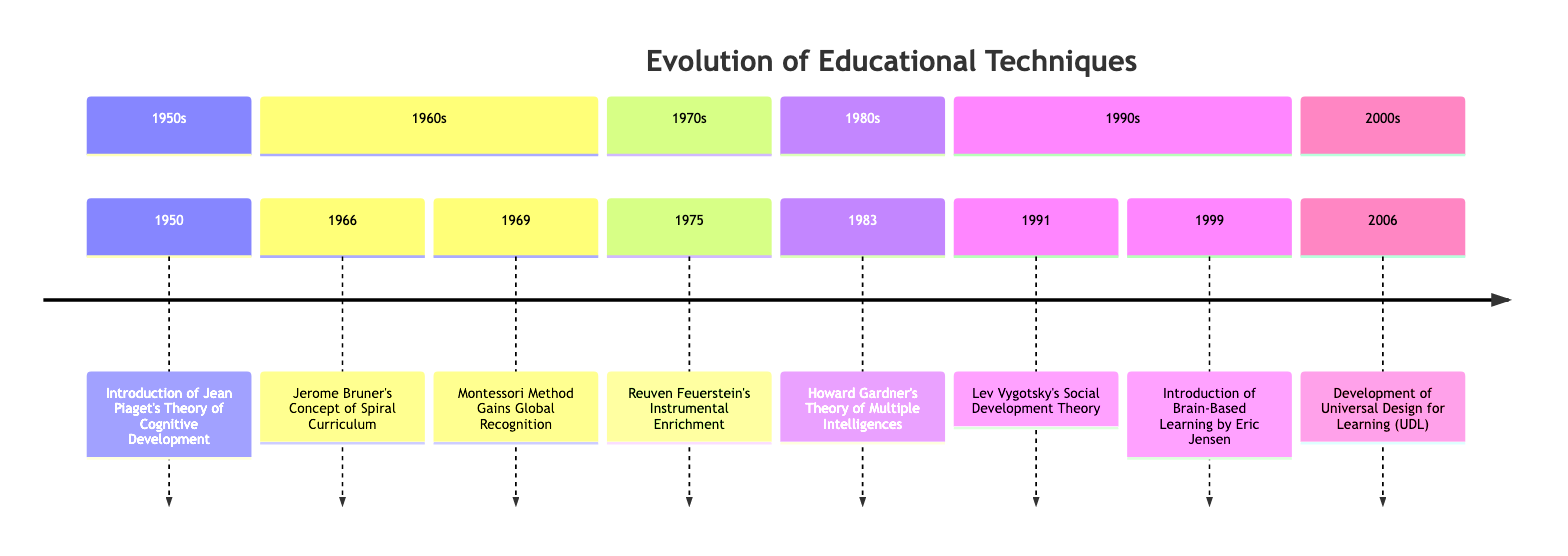What year was Jean Piaget's Theory of Cognitive Development introduced? The timeline indicates that Jean Piaget's Theory of Cognitive Development was introduced in 1950, positioned at the start of the 1950s section.
Answer: 1950 How many educational techniques were introduced in the 1960s? The timeline shows two events within the 1960s section: Jerome Bruner's Concept of Spiral Curriculum in 1966 and Montessori Method Gains Global Recognition in 1969. Therefore, there are two events.
Answer: 2 What method emphasizes child-led learning? In the 1969 entry, the Montessori Method is highlighted as emphasizing hands-on, child-led learning, which allows children to take initiative in their educational journey.
Answer: Montessori Method Which theory suggests that intelligence consists of different modalities? The timeline states that in 1983, Howard Gardner published his Theory of Multiple Intelligences, which suggests that intelligence is a combination of different modalities rather than a single entity.
Answer: Theory of Multiple Intelligences What year marks the development of Universal Design for Learning (UDL)? The timeline has a specific event in the 2000s section indicating that the Development of Universal Design for Learning (UDL) occurred in 2006, marking its establishment.
Answer: 2006 Which educational technique was recognized for its focus on social interaction? The timeline presents the 1991 entry for Lev Vygotsky's Social Development Theory, emphasizing the necessity of social interaction in the process of cognitive development.
Answer: Lev Vygotsky's Social Development Theory In what year did Eric Jensen introduce brain-based learning? According to the timeline, Eric Jensen introduced brain-based learning in 1999, noted specifically in that year's entry under the 1990s section.
Answer: 1999 Which event is located just before Reuven Feuerstein's Instrumental Enrichment? The timeline displays that the event preceding Reuven Feuerstein's Instrumental Enrichment, which is in 1975, is Jerome Bruner's Concept of Spiral Curriculum in 1966 in the 1960s section.
Answer: Jerome Bruner's Concept of Spiral Curriculum 